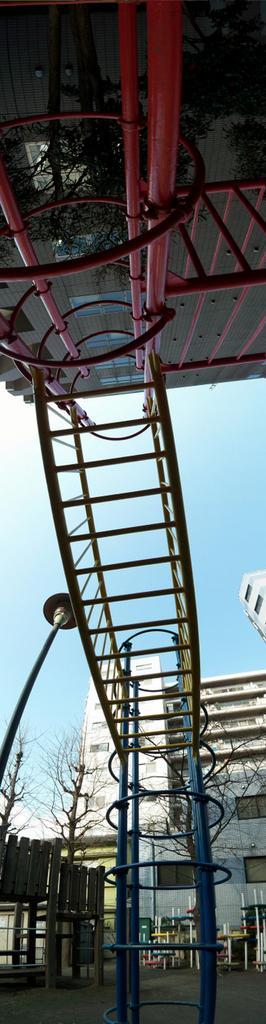In one or two sentences, can you explain what this image depicts? In this image we can see rods, metal objects and trees. In the background there are buildings, pole, metal objects and clouds in the sky. 